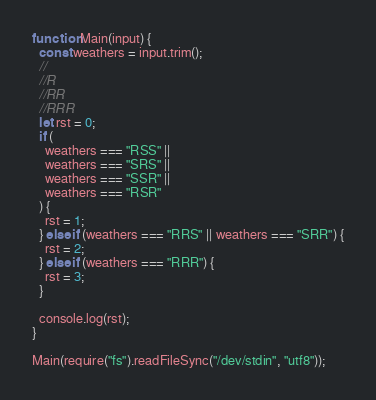Convert code to text. <code><loc_0><loc_0><loc_500><loc_500><_JavaScript_>function Main(input) {
  const weathers = input.trim();
  //
  //R
  //RR
  //RRR
  let rst = 0;
  if (
    weathers === "RSS" ||
    weathers === "SRS" ||
    weathers === "SSR" ||
    weathers === "RSR"
  ) {
    rst = 1;
  } else if (weathers === "RRS" || weathers === "SRR") {
    rst = 2;
  } else if (weathers === "RRR") {
    rst = 3;
  }

  console.log(rst);
}

Main(require("fs").readFileSync("/dev/stdin", "utf8"));
</code> 